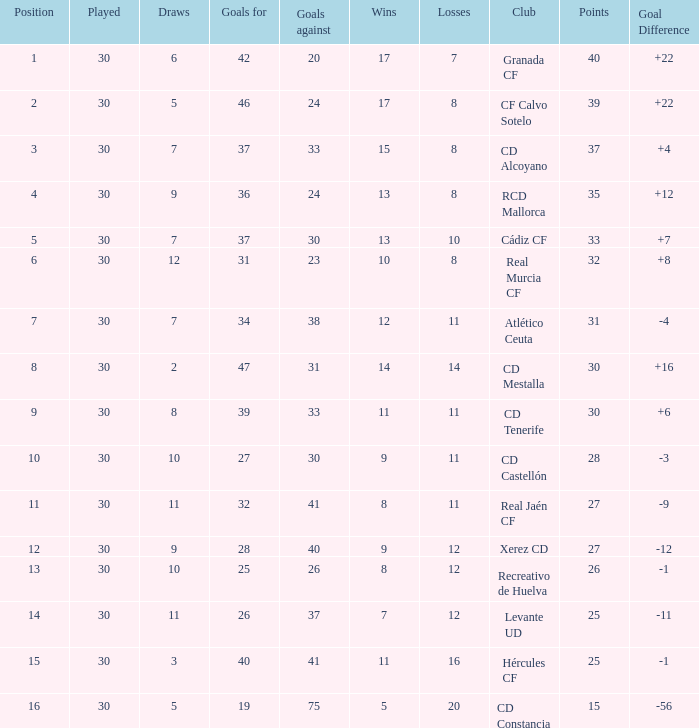Which Played has a Club of atlético ceuta, and less than 11 Losses? None. 